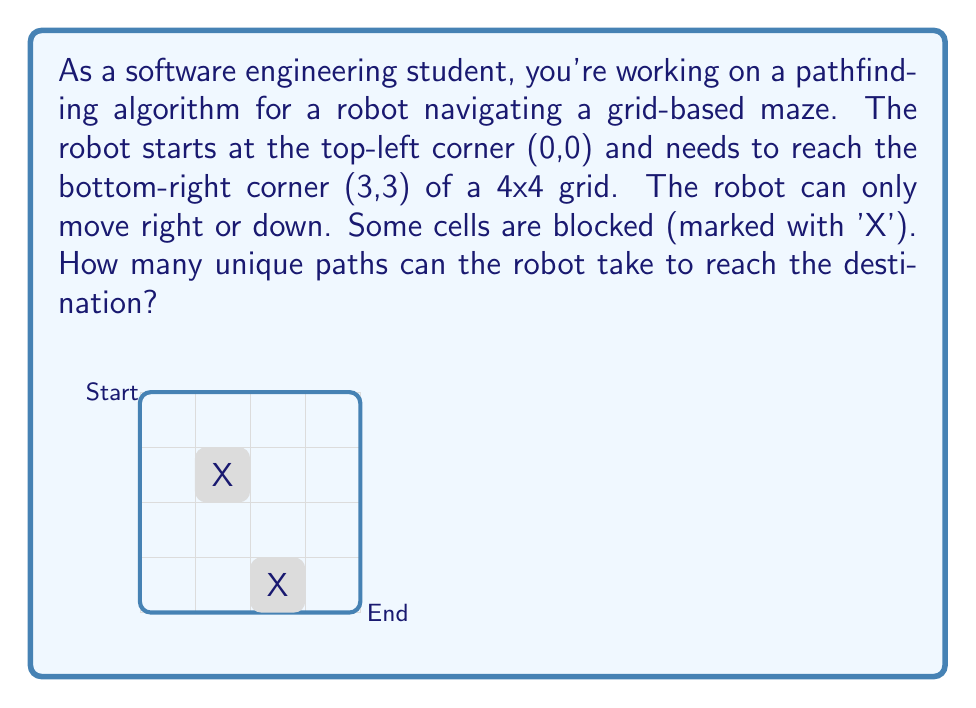What is the answer to this math problem? Let's approach this step-by-step:

1) First, we need to understand that this problem can be solved using dynamic programming. We'll create a 4x4 grid where each cell represents the number of ways to reach that cell.

2) Initialize the grid:
   - Set the start position (0,0) to 1
   - Set blocked cells to 0
   - Set the first row and first column (except blocked cells) to 1, as there's only one way to reach these cells

3) For each cell (i,j), the number of ways to reach it is the sum of ways to reach the cell above it and the cell to its left:
   $$grid[i][j] = grid[i-1][j] + grid[i][j-1]$$

4) Let's fill the grid:

   $$
   \begin{bmatrix}
   1 & 1 & 1 & 1 \\
   1 & 0 & 0 & 1 \\
   1 & 1 & 1 & 2 \\
   1 & 2 & 3 & 5
   \end{bmatrix}
   $$

5) The bottom-right cell (3,3) contains the total number of unique paths.

Therefore, there are 5 unique paths from start to end.
Answer: 5 